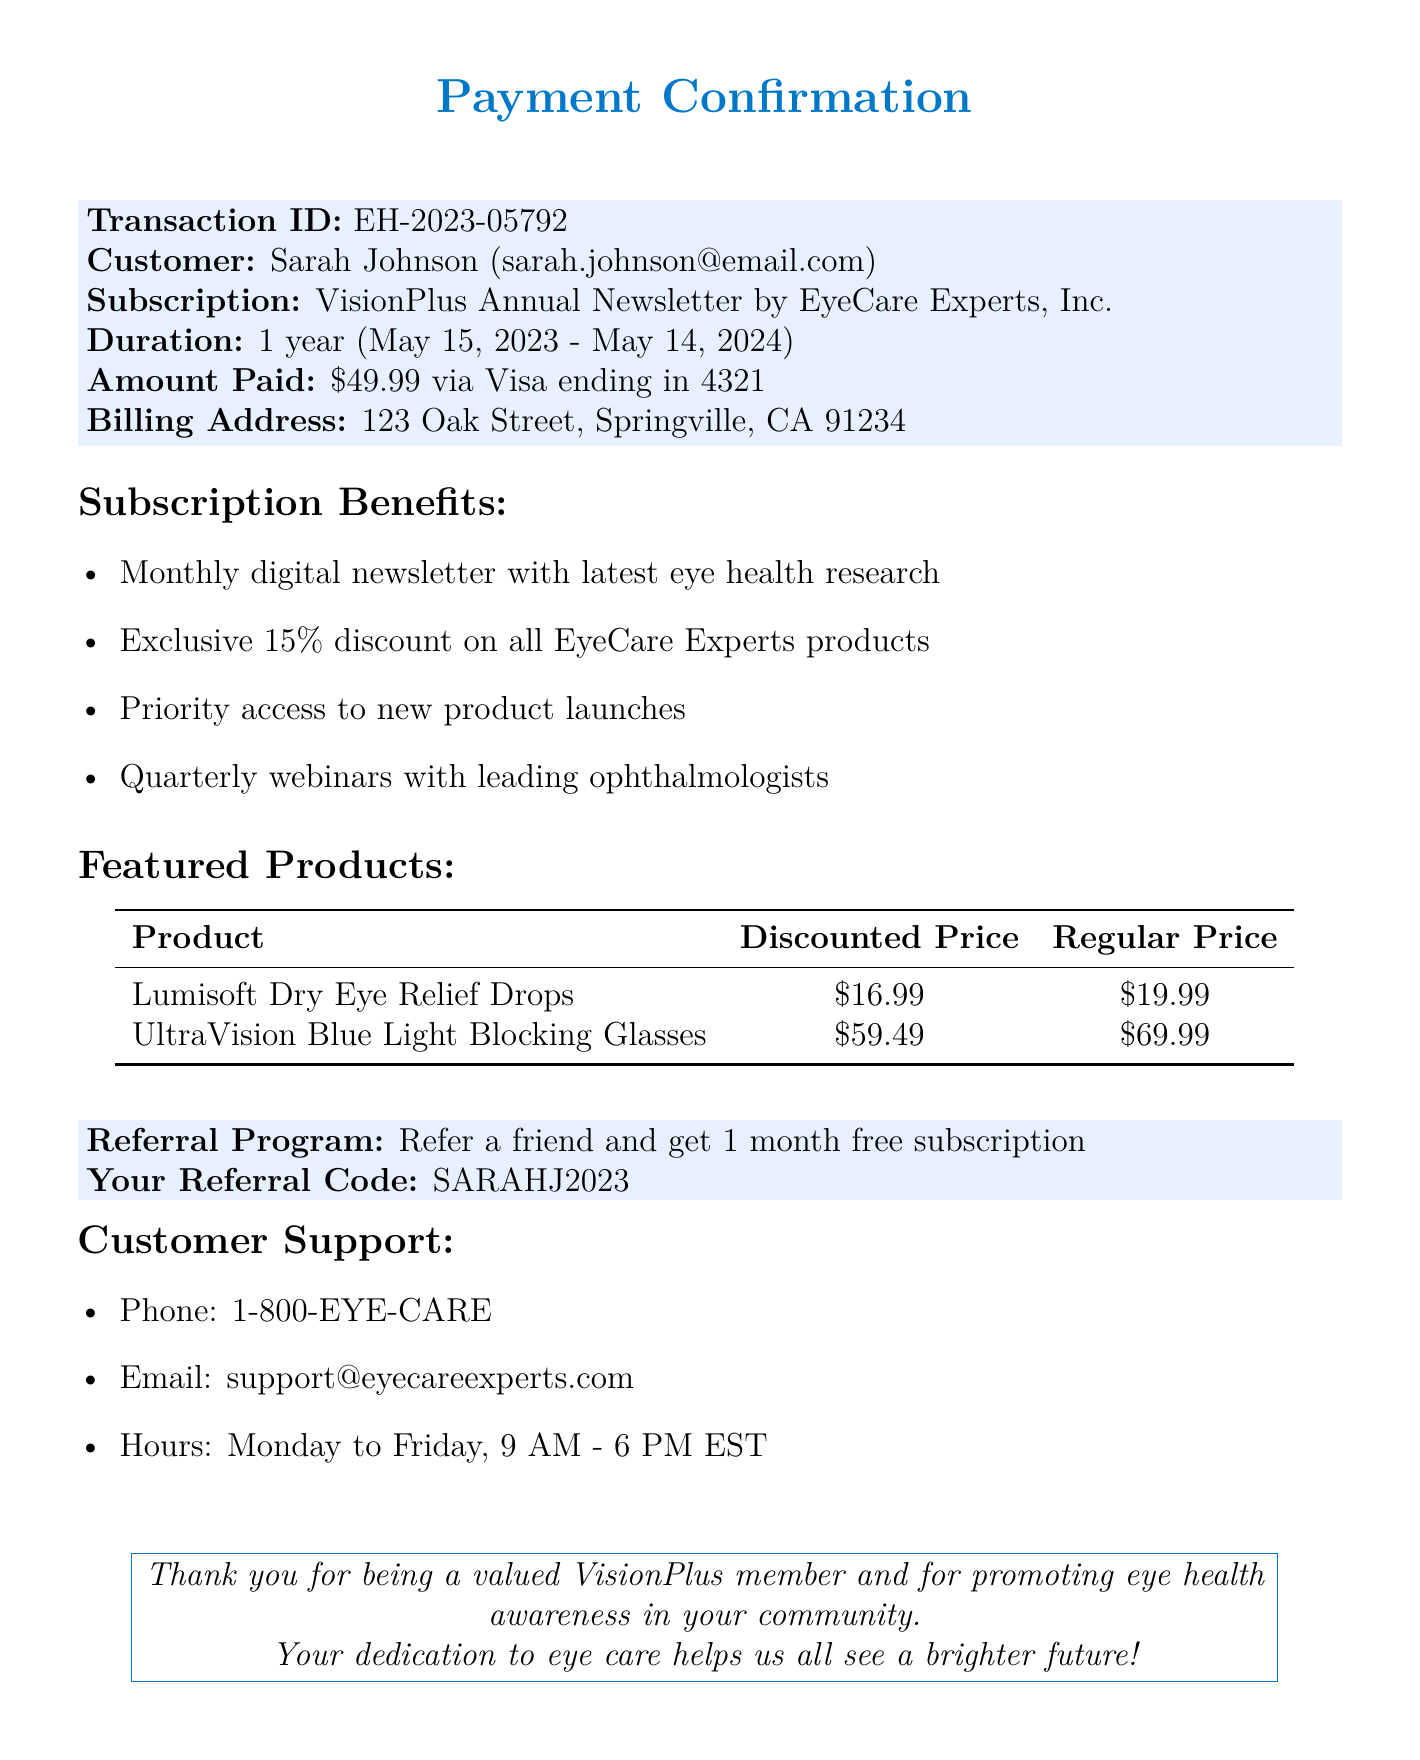What is the transaction ID? The transaction ID is a unique identifier for the transaction, which is stated as EH-2023-05792.
Answer: EH-2023-05792 What is the duration of the subscription? The document specifies the subscription duration as "1 year".
Answer: 1 year What is the amount paid for the subscription? The total amount paid for the subscription is outlined in the document as $49.99.
Answer: $49.99 Who is the provider of the newsletter? The provider of the VisionPlus Annual Newsletter is mentioned as EyeCare Experts, Inc.
Answer: EyeCare Experts, Inc What discount is offered on EyeCare Experts products? The subscription includes an exclusive discount on products, which is stated to be 15 percent.
Answer: 15% What is the referral code mentioned in the document? The referral program includes a specific code for referrals, which is SARAHJ2023.
Answer: SARAHJ2023 What are the customer support hours? The document lists specific customer support hours as Monday to Friday, 9 AM - 6 PM EST.
Answer: Monday to Friday, 9 AM - 6 PM EST How long is the subscription valid? The subscription starts on May 15, 2023, and ends on May 14, 2024, providing a clear validity period.
Answer: May 15, 2023 - May 14, 2024 What product is featured with a discounted price of $16.99? The document features "Lumisoft Dry Eye Relief Drops" with a discounted price of $16.99.
Answer: Lumisoft Dry Eye Relief Drops 